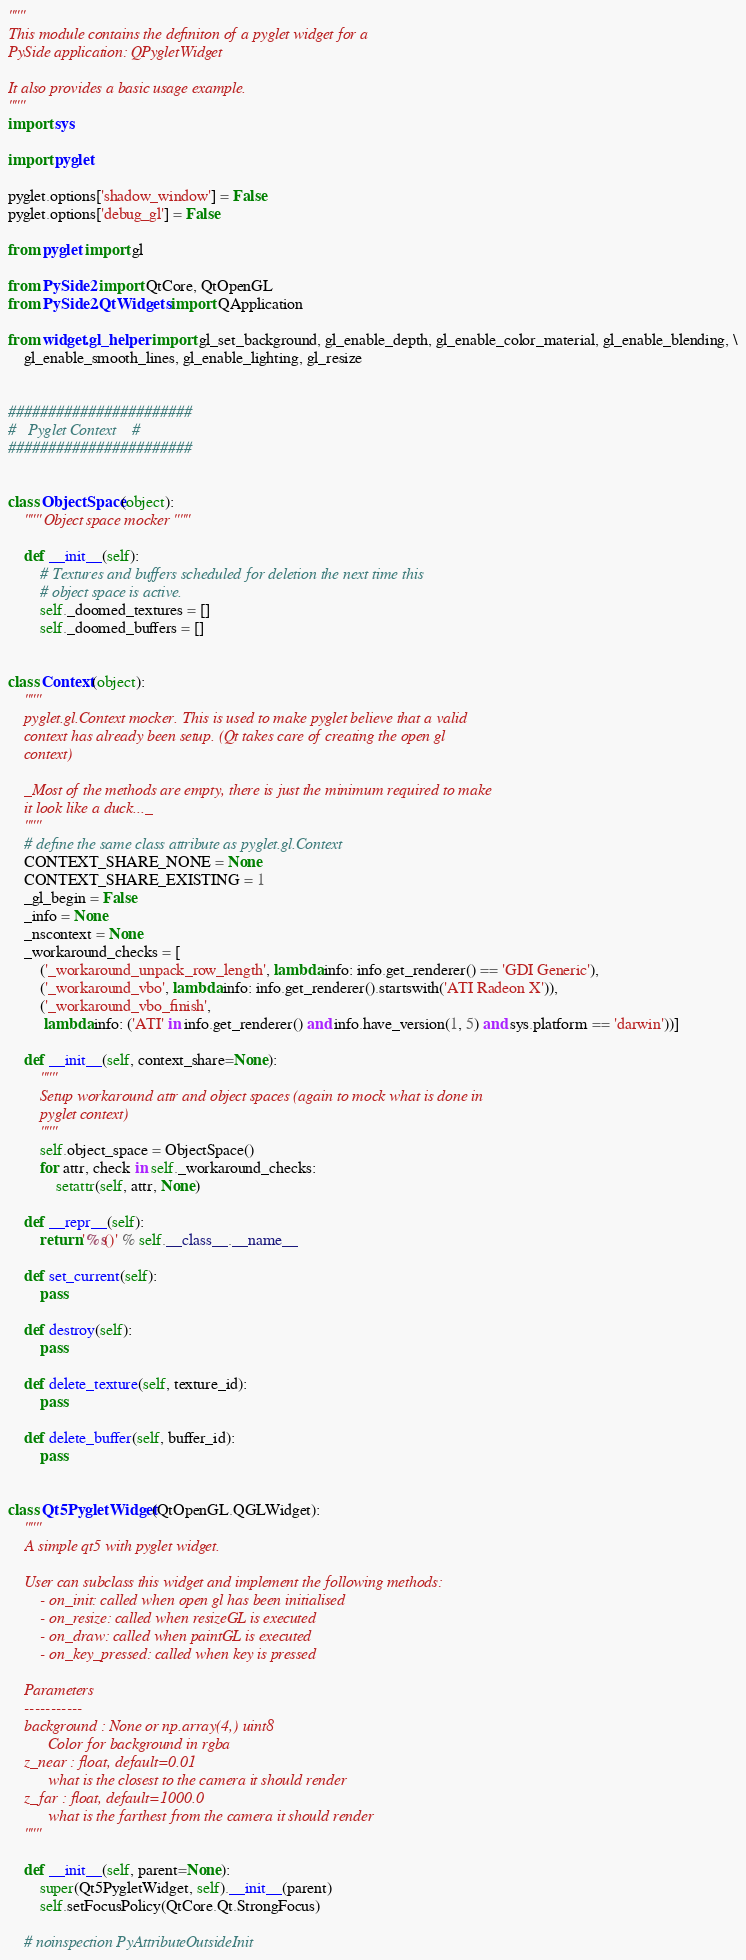<code> <loc_0><loc_0><loc_500><loc_500><_Python_>"""
This module contains the definiton of a pyglet widget for a
PySide application: QPygletWidget

It also provides a basic usage example.
"""
import sys

import pyglet

pyglet.options['shadow_window'] = False
pyglet.options['debug_gl'] = False

from pyglet import gl

from PySide2 import QtCore, QtOpenGL
from PySide2.QtWidgets import QApplication

from widget.gl_helper import gl_set_background, gl_enable_depth, gl_enable_color_material, gl_enable_blending, \
    gl_enable_smooth_lines, gl_enable_lighting, gl_resize


#######################
#   Pyglet Context    #
#######################


class ObjectSpace(object):
    """ Object space mocker """

    def __init__(self):
        # Textures and buffers scheduled for deletion the next time this
        # object space is active.
        self._doomed_textures = []
        self._doomed_buffers = []


class Context(object):
    """
    pyglet.gl.Context mocker. This is used to make pyglet believe that a valid
    context has already been setup. (Qt takes care of creating the open gl
    context)

    _Most of the methods are empty, there is just the minimum required to make
    it look like a duck..._
    """
    # define the same class attribute as pyglet.gl.Context
    CONTEXT_SHARE_NONE = None
    CONTEXT_SHARE_EXISTING = 1
    _gl_begin = False
    _info = None
    _nscontext = None
    _workaround_checks = [
        ('_workaround_unpack_row_length', lambda info: info.get_renderer() == 'GDI Generic'),
        ('_workaround_vbo', lambda info: info.get_renderer().startswith('ATI Radeon X')),
        ('_workaround_vbo_finish',
         lambda info: ('ATI' in info.get_renderer() and info.have_version(1, 5) and sys.platform == 'darwin'))]

    def __init__(self, context_share=None):
        """
        Setup workaround attr and object spaces (again to mock what is done in
        pyglet context)
        """
        self.object_space = ObjectSpace()
        for attr, check in self._workaround_checks:
            setattr(self, attr, None)

    def __repr__(self):
        return '%s()' % self.__class__.__name__

    def set_current(self):
        pass

    def destroy(self):
        pass

    def delete_texture(self, texture_id):
        pass

    def delete_buffer(self, buffer_id):
        pass


class Qt5PygletWidget(QtOpenGL.QGLWidget):
    """
    A simple qt5 with pyglet widget.

    User can subclass this widget and implement the following methods:
        - on_init: called when open gl has been initialised
        - on_resize: called when resizeGL is executed
        - on_draw: called when paintGL is executed
        - on_key_pressed: called when key is pressed

    Parameters
    -----------
    background : None or np.array(4,) uint8
          Color for background in rgba
    z_near : float, default=0.01
          what is the closest to the camera it should render
    z_far : float, default=1000.0
          what is the farthest from the camera it should render
    """

    def __init__(self, parent=None):
        super(Qt5PygletWidget, self).__init__(parent)
        self.setFocusPolicy(QtCore.Qt.StrongFocus)

    # noinspection PyAttributeOutsideInit</code> 